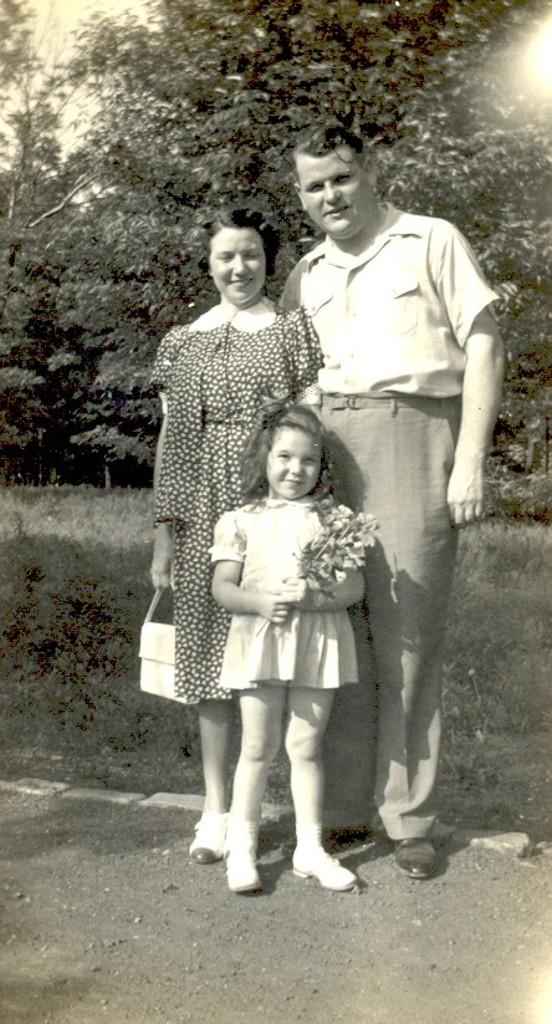How many people are present in the image? There are three people in the image: a man, a woman, and a kid. What is located at the bottom of the image? There is soil at the bottom of the image. What can be seen in the background of the image? There are plants and trees in the background of the image. What type of letter is the toad holding in the image? There is no toad or letter present in the image. What is the aftermath of the event depicted in the image? The image does not depict an event, so there is no aftermath to describe. 